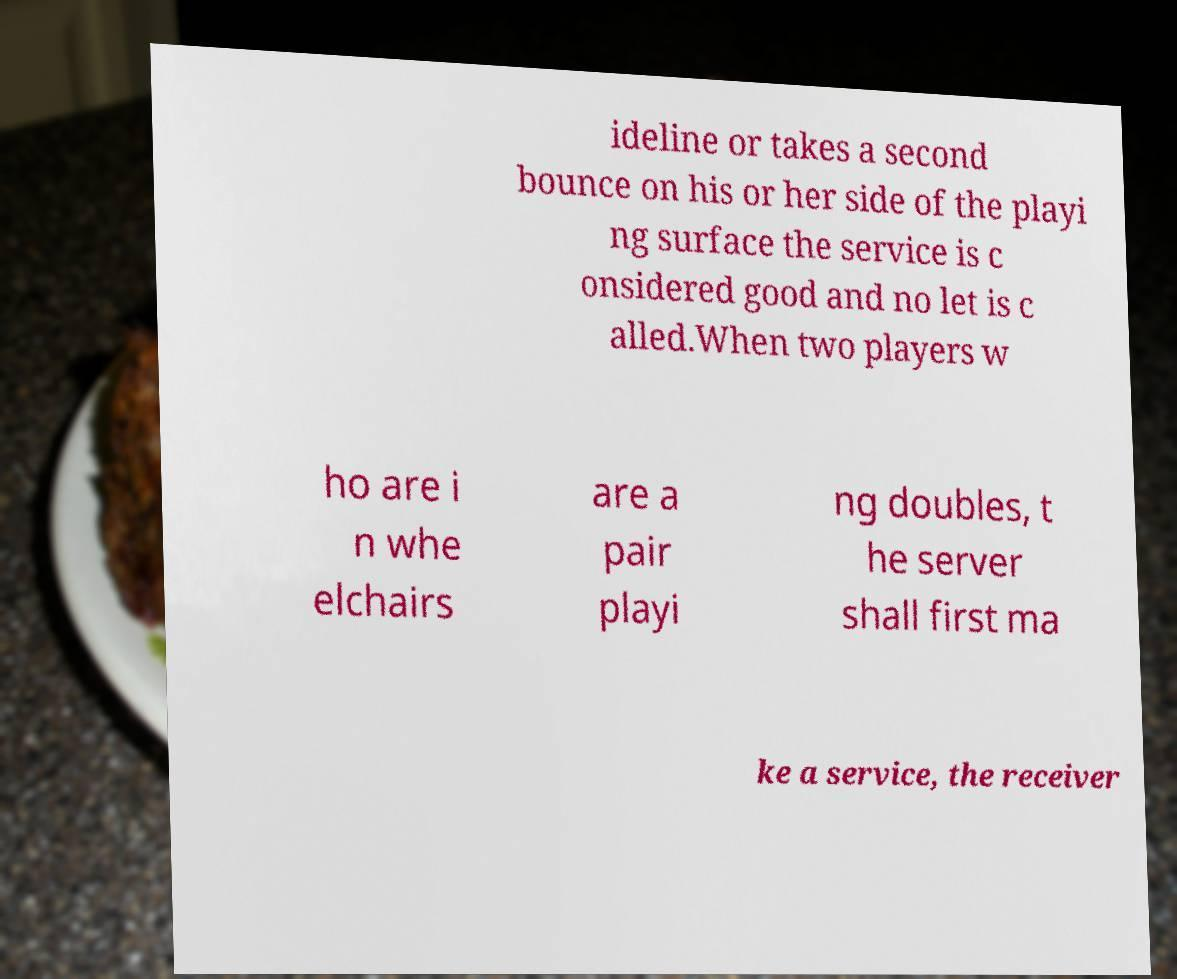Can you accurately transcribe the text from the provided image for me? ideline or takes a second bounce on his or her side of the playi ng surface the service is c onsidered good and no let is c alled.When two players w ho are i n whe elchairs are a pair playi ng doubles, t he server shall first ma ke a service, the receiver 